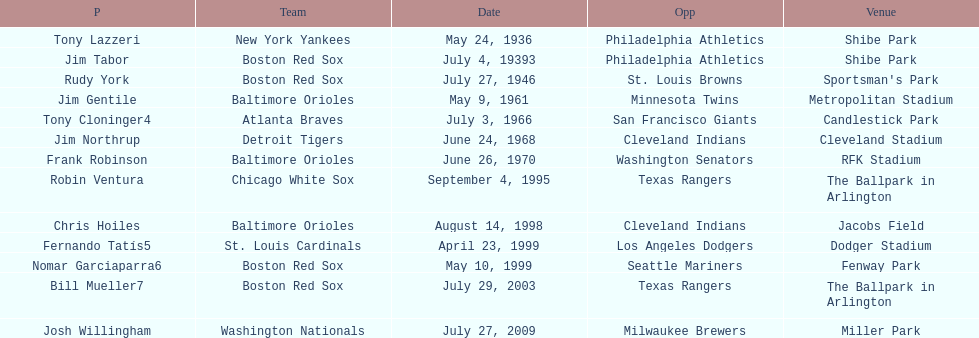Who was the opponent for the boston red sox on july 27, 1946? St. Louis Browns. 